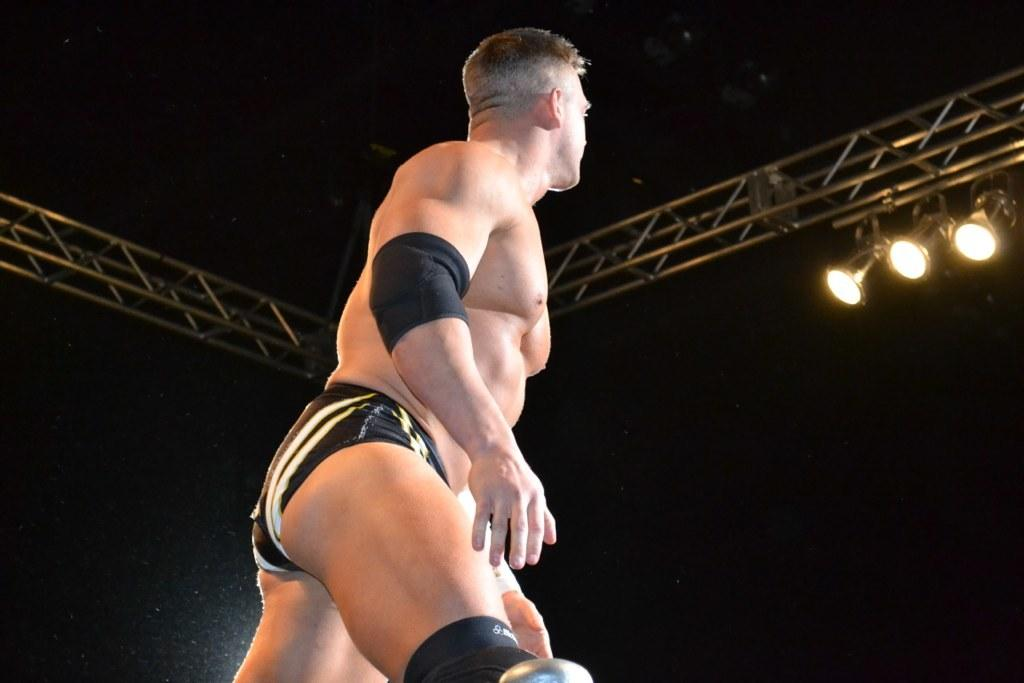What is the main subject in the foreground of the image? There is a man in the foreground of the image. What is the man's posture in the image? The man appears to be standing in the image. What can be seen in the background of the image? There are pillar rods with lights in the background of the image. How many fingers does the bear have in the image? There is no bear present in the image, so it is not possible to determine the number of fingers it might have. 